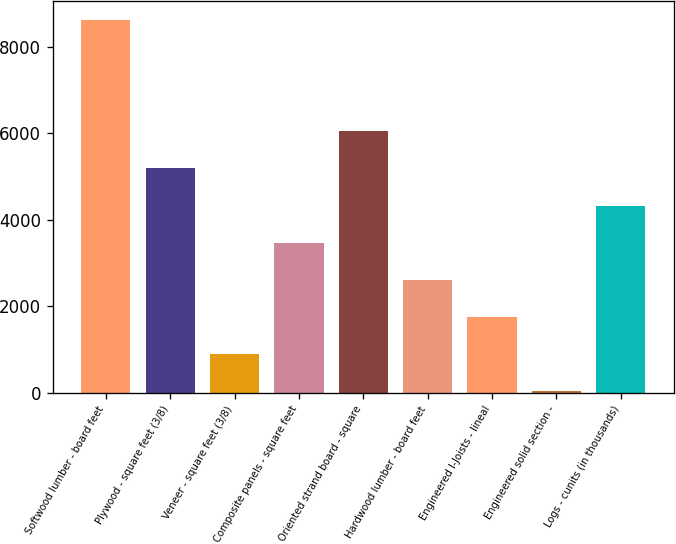Convert chart to OTSL. <chart><loc_0><loc_0><loc_500><loc_500><bar_chart><fcel>Softwood lumber - board feet<fcel>Plywood - square feet (3/8)<fcel>Veneer - square feet (3/8)<fcel>Composite panels - square feet<fcel>Oriented strand board - square<fcel>Hardwood lumber - board feet<fcel>Engineered I-Joists - lineal<fcel>Engineered solid section -<fcel>Logs - cunits (in thousands)<nl><fcel>8623<fcel>5185<fcel>887.5<fcel>3466<fcel>6044.5<fcel>2606.5<fcel>1747<fcel>28<fcel>4325.5<nl></chart> 